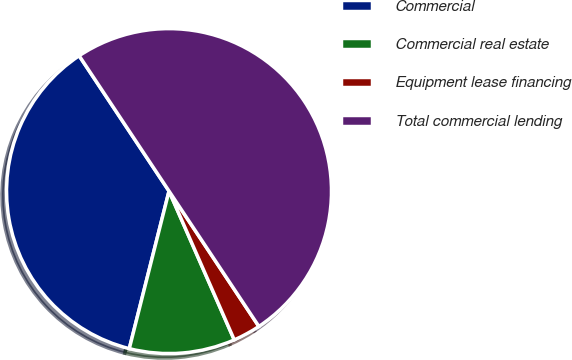Convert chart to OTSL. <chart><loc_0><loc_0><loc_500><loc_500><pie_chart><fcel>Commercial<fcel>Commercial real estate<fcel>Equipment lease financing<fcel>Total commercial lending<nl><fcel>36.74%<fcel>10.51%<fcel>2.75%<fcel>50.0%<nl></chart> 